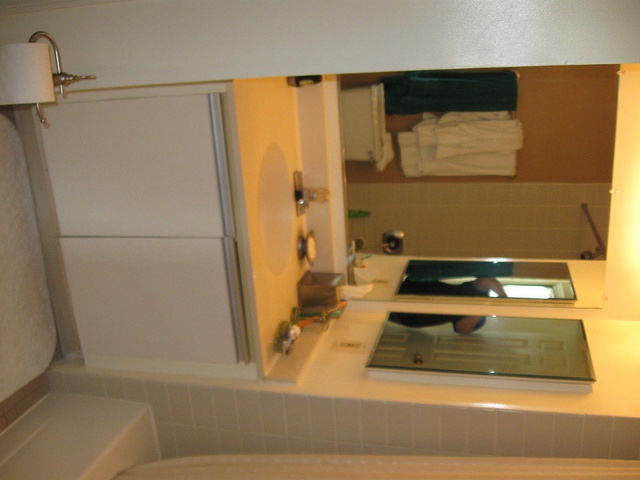Describe the objects in this image and their specific colors. I can see people in gray, black, and maroon tones, toothbrush in gray, brown, olive, maroon, and red tones, and toothbrush in gray, black, and olive tones in this image. 